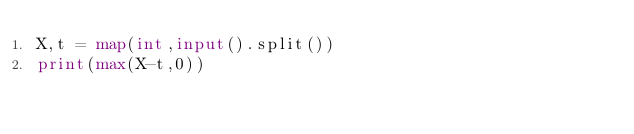<code> <loc_0><loc_0><loc_500><loc_500><_Python_>X,t = map(int,input().split())
print(max(X-t,0))</code> 